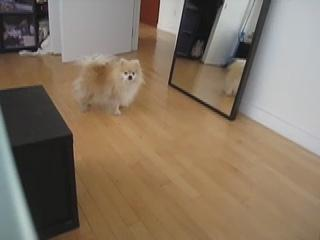Question: what color is the dog?
Choices:
A. Black.
B. Blonde.
C. Red.
D. Tan.
Answer with the letter. Answer: D Question: what type of floor?
Choices:
A. Hardwood.
B. Carpeted floor.
C. Laminate.
D. Wood.
Answer with the letter. Answer: D 